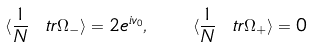Convert formula to latex. <formula><loc_0><loc_0><loc_500><loc_500>\langle \frac { 1 } { N } \ t r \Omega _ { - } \rangle = 2 e ^ { i v _ { 0 } } , \quad \langle \frac { 1 } { N } \ t r \Omega _ { + } \rangle = 0</formula> 